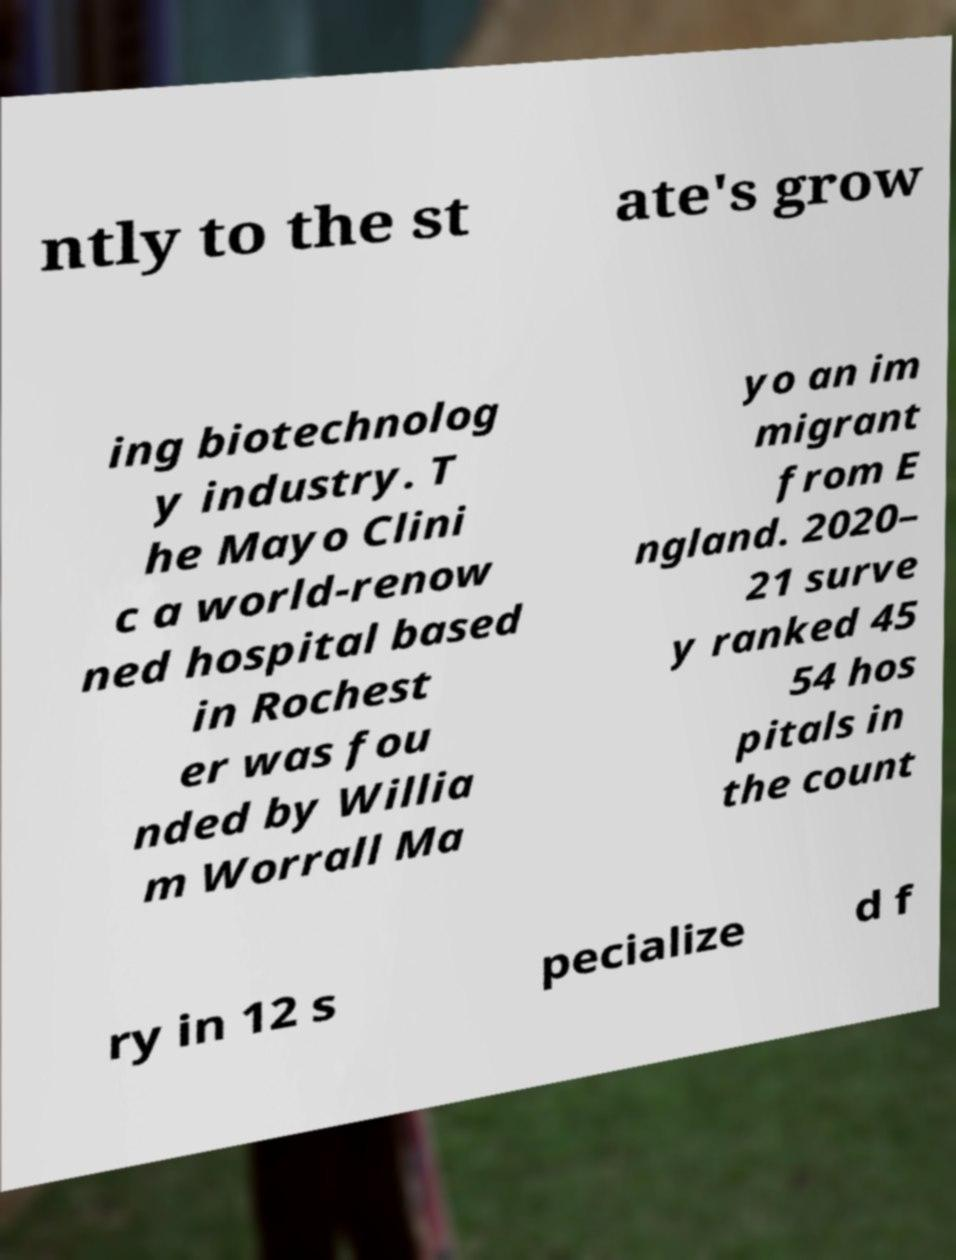Can you read and provide the text displayed in the image?This photo seems to have some interesting text. Can you extract and type it out for me? ntly to the st ate's grow ing biotechnolog y industry. T he Mayo Clini c a world-renow ned hospital based in Rochest er was fou nded by Willia m Worrall Ma yo an im migrant from E ngland. 2020– 21 surve y ranked 45 54 hos pitals in the count ry in 12 s pecialize d f 